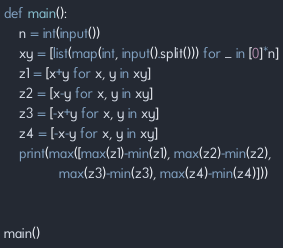Convert code to text. <code><loc_0><loc_0><loc_500><loc_500><_Python_>def main():
    n = int(input())
    xy = [list(map(int, input().split())) for _ in [0]*n]
    z1 = [x+y for x, y in xy]
    z2 = [x-y for x, y in xy]
    z3 = [-x+y for x, y in xy]
    z4 = [-x-y for x, y in xy]
    print(max([max(z1)-min(z1), max(z2)-min(z2),
               max(z3)-min(z3), max(z4)-min(z4)]))


main()
</code> 